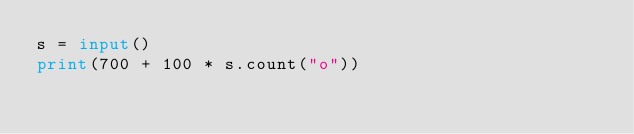Convert code to text. <code><loc_0><loc_0><loc_500><loc_500><_Python_>s = input()
print(700 + 100 * s.count("o"))</code> 